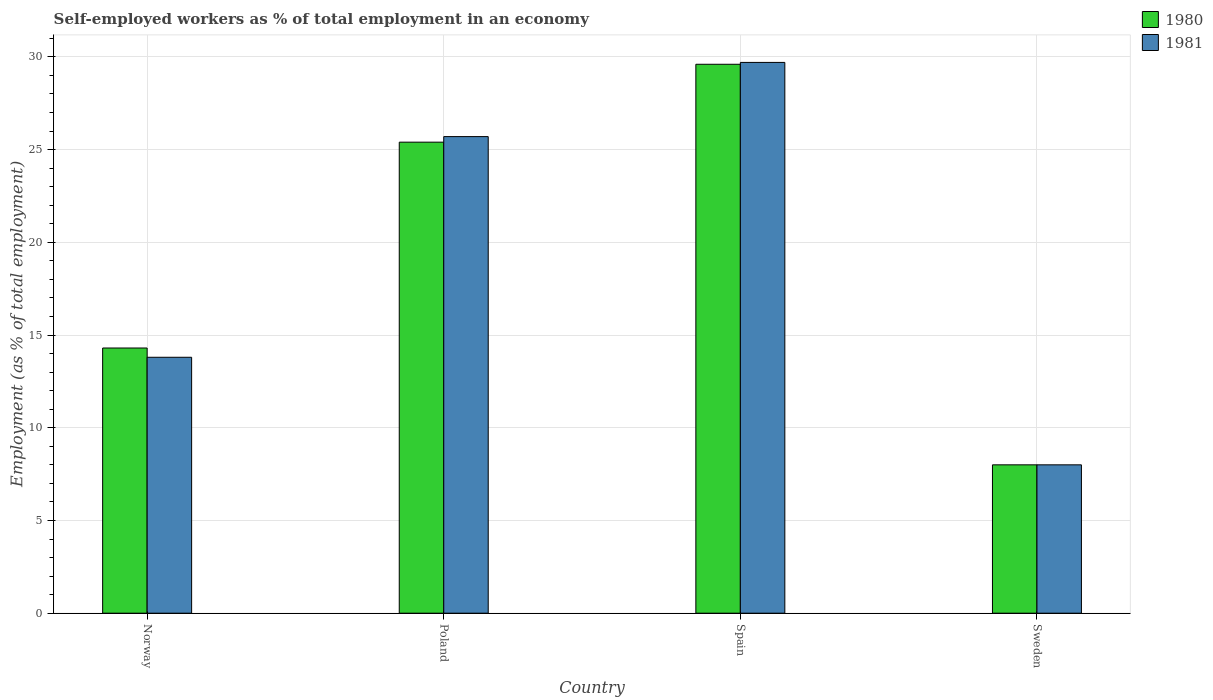How many different coloured bars are there?
Give a very brief answer. 2. How many groups of bars are there?
Your answer should be very brief. 4. How many bars are there on the 1st tick from the left?
Offer a very short reply. 2. What is the percentage of self-employed workers in 1980 in Poland?
Ensure brevity in your answer.  25.4. Across all countries, what is the maximum percentage of self-employed workers in 1980?
Provide a short and direct response. 29.6. In which country was the percentage of self-employed workers in 1980 maximum?
Provide a short and direct response. Spain. What is the total percentage of self-employed workers in 1981 in the graph?
Ensure brevity in your answer.  77.2. What is the difference between the percentage of self-employed workers in 1980 in Poland and that in Sweden?
Make the answer very short. 17.4. What is the difference between the percentage of self-employed workers in 1980 in Norway and the percentage of self-employed workers in 1981 in Spain?
Offer a very short reply. -15.4. What is the average percentage of self-employed workers in 1980 per country?
Provide a succinct answer. 19.33. What is the difference between the percentage of self-employed workers of/in 1981 and percentage of self-employed workers of/in 1980 in Spain?
Make the answer very short. 0.1. In how many countries, is the percentage of self-employed workers in 1980 greater than 26 %?
Your answer should be very brief. 1. What is the ratio of the percentage of self-employed workers in 1981 in Poland to that in Sweden?
Ensure brevity in your answer.  3.21. Is the percentage of self-employed workers in 1980 in Poland less than that in Spain?
Keep it short and to the point. Yes. Is the difference between the percentage of self-employed workers in 1981 in Poland and Spain greater than the difference between the percentage of self-employed workers in 1980 in Poland and Spain?
Provide a succinct answer. Yes. What is the difference between the highest and the second highest percentage of self-employed workers in 1981?
Your answer should be compact. 11.9. What is the difference between the highest and the lowest percentage of self-employed workers in 1981?
Your response must be concise. 21.7. What does the 2nd bar from the right in Norway represents?
Provide a short and direct response. 1980. How many bars are there?
Offer a terse response. 8. Are all the bars in the graph horizontal?
Your response must be concise. No. What is the difference between two consecutive major ticks on the Y-axis?
Keep it short and to the point. 5. Does the graph contain any zero values?
Offer a terse response. No. Does the graph contain grids?
Offer a terse response. Yes. How many legend labels are there?
Keep it short and to the point. 2. How are the legend labels stacked?
Offer a terse response. Vertical. What is the title of the graph?
Make the answer very short. Self-employed workers as % of total employment in an economy. Does "2007" appear as one of the legend labels in the graph?
Offer a very short reply. No. What is the label or title of the X-axis?
Provide a succinct answer. Country. What is the label or title of the Y-axis?
Provide a succinct answer. Employment (as % of total employment). What is the Employment (as % of total employment) in 1980 in Norway?
Your answer should be compact. 14.3. What is the Employment (as % of total employment) in 1981 in Norway?
Ensure brevity in your answer.  13.8. What is the Employment (as % of total employment) of 1980 in Poland?
Provide a succinct answer. 25.4. What is the Employment (as % of total employment) of 1981 in Poland?
Your response must be concise. 25.7. What is the Employment (as % of total employment) in 1980 in Spain?
Offer a terse response. 29.6. What is the Employment (as % of total employment) of 1981 in Spain?
Your answer should be very brief. 29.7. Across all countries, what is the maximum Employment (as % of total employment) in 1980?
Your answer should be compact. 29.6. Across all countries, what is the maximum Employment (as % of total employment) in 1981?
Offer a very short reply. 29.7. Across all countries, what is the minimum Employment (as % of total employment) in 1980?
Offer a very short reply. 8. What is the total Employment (as % of total employment) in 1980 in the graph?
Offer a terse response. 77.3. What is the total Employment (as % of total employment) of 1981 in the graph?
Offer a very short reply. 77.2. What is the difference between the Employment (as % of total employment) in 1980 in Norway and that in Poland?
Ensure brevity in your answer.  -11.1. What is the difference between the Employment (as % of total employment) in 1980 in Norway and that in Spain?
Provide a short and direct response. -15.3. What is the difference between the Employment (as % of total employment) in 1981 in Norway and that in Spain?
Your answer should be compact. -15.9. What is the difference between the Employment (as % of total employment) in 1980 in Norway and that in Sweden?
Keep it short and to the point. 6.3. What is the difference between the Employment (as % of total employment) in 1981 in Poland and that in Spain?
Provide a succinct answer. -4. What is the difference between the Employment (as % of total employment) of 1980 in Poland and that in Sweden?
Keep it short and to the point. 17.4. What is the difference between the Employment (as % of total employment) in 1980 in Spain and that in Sweden?
Make the answer very short. 21.6. What is the difference between the Employment (as % of total employment) in 1981 in Spain and that in Sweden?
Ensure brevity in your answer.  21.7. What is the difference between the Employment (as % of total employment) of 1980 in Norway and the Employment (as % of total employment) of 1981 in Poland?
Your answer should be compact. -11.4. What is the difference between the Employment (as % of total employment) in 1980 in Norway and the Employment (as % of total employment) in 1981 in Spain?
Offer a terse response. -15.4. What is the difference between the Employment (as % of total employment) in 1980 in Poland and the Employment (as % of total employment) in 1981 in Spain?
Offer a terse response. -4.3. What is the difference between the Employment (as % of total employment) of 1980 in Poland and the Employment (as % of total employment) of 1981 in Sweden?
Offer a very short reply. 17.4. What is the difference between the Employment (as % of total employment) of 1980 in Spain and the Employment (as % of total employment) of 1981 in Sweden?
Ensure brevity in your answer.  21.6. What is the average Employment (as % of total employment) in 1980 per country?
Give a very brief answer. 19.32. What is the average Employment (as % of total employment) in 1981 per country?
Keep it short and to the point. 19.3. What is the difference between the Employment (as % of total employment) in 1980 and Employment (as % of total employment) in 1981 in Norway?
Your response must be concise. 0.5. What is the difference between the Employment (as % of total employment) of 1980 and Employment (as % of total employment) of 1981 in Poland?
Provide a short and direct response. -0.3. What is the difference between the Employment (as % of total employment) in 1980 and Employment (as % of total employment) in 1981 in Sweden?
Your answer should be compact. 0. What is the ratio of the Employment (as % of total employment) in 1980 in Norway to that in Poland?
Your answer should be compact. 0.56. What is the ratio of the Employment (as % of total employment) of 1981 in Norway to that in Poland?
Your answer should be very brief. 0.54. What is the ratio of the Employment (as % of total employment) of 1980 in Norway to that in Spain?
Provide a short and direct response. 0.48. What is the ratio of the Employment (as % of total employment) of 1981 in Norway to that in Spain?
Your answer should be very brief. 0.46. What is the ratio of the Employment (as % of total employment) of 1980 in Norway to that in Sweden?
Your response must be concise. 1.79. What is the ratio of the Employment (as % of total employment) of 1981 in Norway to that in Sweden?
Your answer should be very brief. 1.73. What is the ratio of the Employment (as % of total employment) of 1980 in Poland to that in Spain?
Provide a succinct answer. 0.86. What is the ratio of the Employment (as % of total employment) of 1981 in Poland to that in Spain?
Your response must be concise. 0.87. What is the ratio of the Employment (as % of total employment) in 1980 in Poland to that in Sweden?
Provide a succinct answer. 3.17. What is the ratio of the Employment (as % of total employment) in 1981 in Poland to that in Sweden?
Your answer should be compact. 3.21. What is the ratio of the Employment (as % of total employment) of 1981 in Spain to that in Sweden?
Ensure brevity in your answer.  3.71. What is the difference between the highest and the second highest Employment (as % of total employment) in 1980?
Keep it short and to the point. 4.2. What is the difference between the highest and the second highest Employment (as % of total employment) of 1981?
Keep it short and to the point. 4. What is the difference between the highest and the lowest Employment (as % of total employment) of 1980?
Provide a short and direct response. 21.6. What is the difference between the highest and the lowest Employment (as % of total employment) in 1981?
Give a very brief answer. 21.7. 